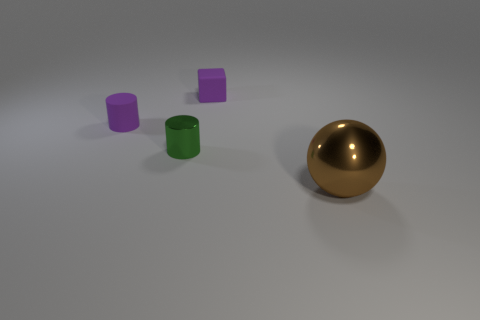Add 2 tiny blue blocks. How many objects exist? 6 Add 2 big gray rubber cubes. How many big gray rubber cubes exist? 2 Subtract 0 red spheres. How many objects are left? 4 Subtract all purple cylinders. Subtract all large brown shiny things. How many objects are left? 2 Add 1 large spheres. How many large spheres are left? 2 